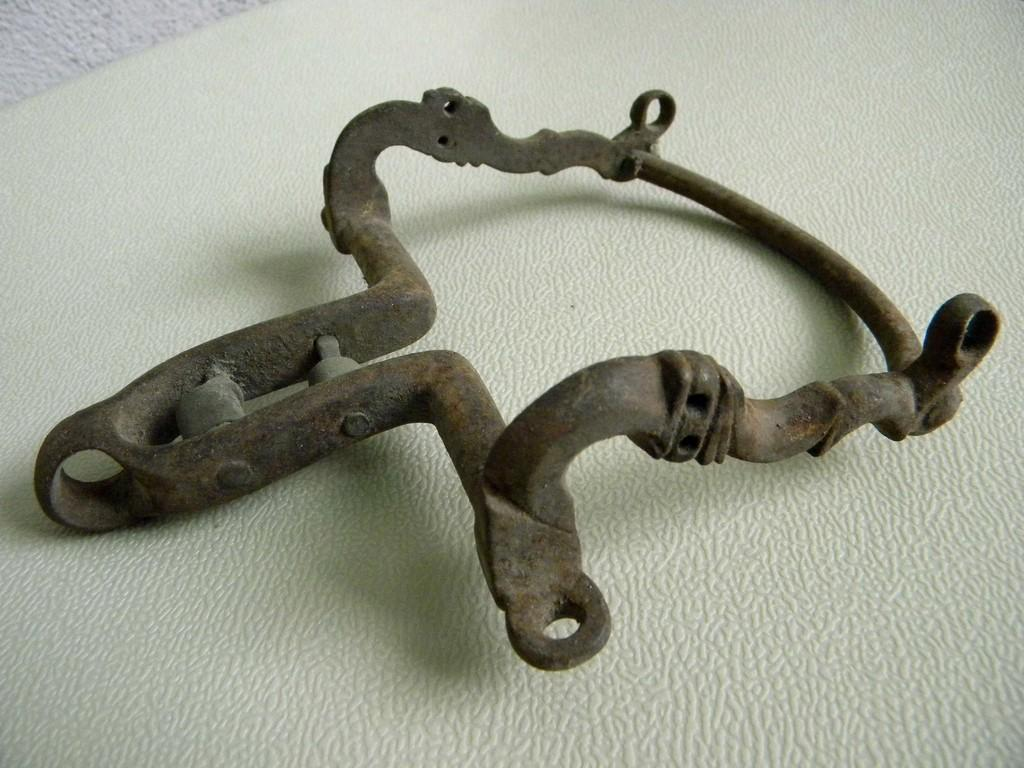What type of object is present in the image? There is a metal object in the image. Can you describe the appearance of the metal object? The metal object resembles a handle or an antique. What is the color of the background in the image? The background of the image is white in color. What might the white background be? The white background might be a table. What type of food is being prepared on the white background in the image? There is no food present in the image, and the white background might be a table rather than a surface for food preparation. How does the rabbit contribute to the acoustics of the image? There is no rabbit present in the image, so it cannot contribute to the acoustics. 